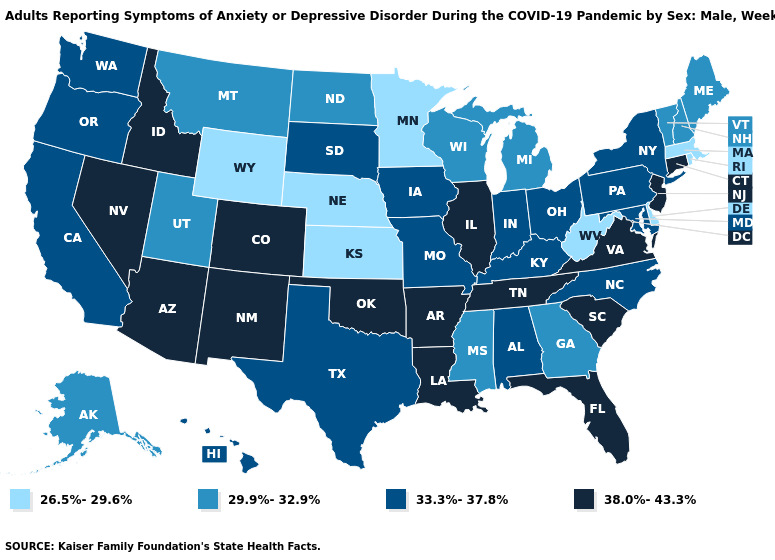What is the value of Ohio?
Give a very brief answer. 33.3%-37.8%. Is the legend a continuous bar?
Quick response, please. No. What is the value of Hawaii?
Answer briefly. 33.3%-37.8%. What is the highest value in states that border New Mexico?
Concise answer only. 38.0%-43.3%. Name the states that have a value in the range 26.5%-29.6%?
Concise answer only. Delaware, Kansas, Massachusetts, Minnesota, Nebraska, Rhode Island, West Virginia, Wyoming. Does Kentucky have the same value as Alabama?
Keep it brief. Yes. What is the value of Michigan?
Concise answer only. 29.9%-32.9%. Does Alaska have a lower value than Wisconsin?
Answer briefly. No. What is the highest value in the USA?
Quick response, please. 38.0%-43.3%. Among the states that border Arizona , does Utah have the lowest value?
Concise answer only. Yes. Does Colorado have a higher value than Nevada?
Write a very short answer. No. Does the first symbol in the legend represent the smallest category?
Give a very brief answer. Yes. Among the states that border New York , which have the highest value?
Concise answer only. Connecticut, New Jersey. Does the map have missing data?
Quick response, please. No. Does Georgia have a higher value than Delaware?
Give a very brief answer. Yes. 